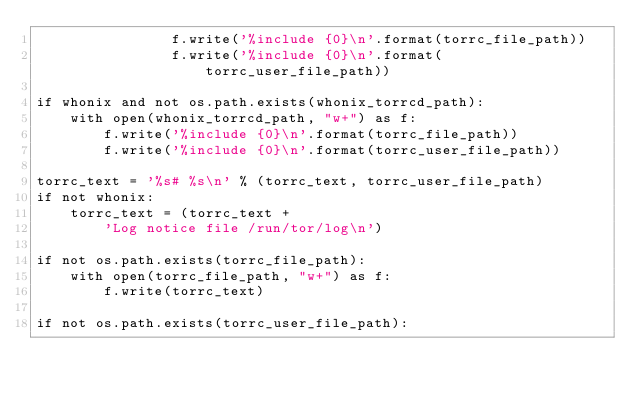Convert code to text. <code><loc_0><loc_0><loc_500><loc_500><_Python_>                f.write('%include {0}\n'.format(torrc_file_path))
                f.write('%include {0}\n'.format(torrc_user_file_path))

if whonix and not os.path.exists(whonix_torrcd_path):
    with open(whonix_torrcd_path, "w+") as f:
        f.write('%include {0}\n'.format(torrc_file_path))
        f.write('%include {0}\n'.format(torrc_user_file_path))

torrc_text = '%s# %s\n' % (torrc_text, torrc_user_file_path)
if not whonix:
    torrc_text = (torrc_text +
        'Log notice file /run/tor/log\n')

if not os.path.exists(torrc_file_path):
    with open(torrc_file_path, "w+") as f:
        f.write(torrc_text)

if not os.path.exists(torrc_user_file_path):</code> 